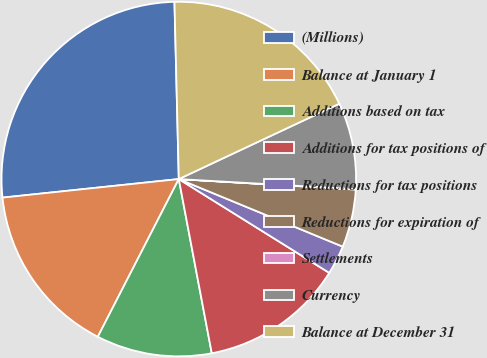<chart> <loc_0><loc_0><loc_500><loc_500><pie_chart><fcel>(Millions)<fcel>Balance at January 1<fcel>Additions based on tax<fcel>Additions for tax positions of<fcel>Reductions for tax positions<fcel>Reductions for expiration of<fcel>Settlements<fcel>Currency<fcel>Balance at December 31<nl><fcel>26.28%<fcel>15.78%<fcel>10.53%<fcel>13.15%<fcel>2.65%<fcel>5.28%<fcel>0.03%<fcel>7.9%<fcel>18.4%<nl></chart> 